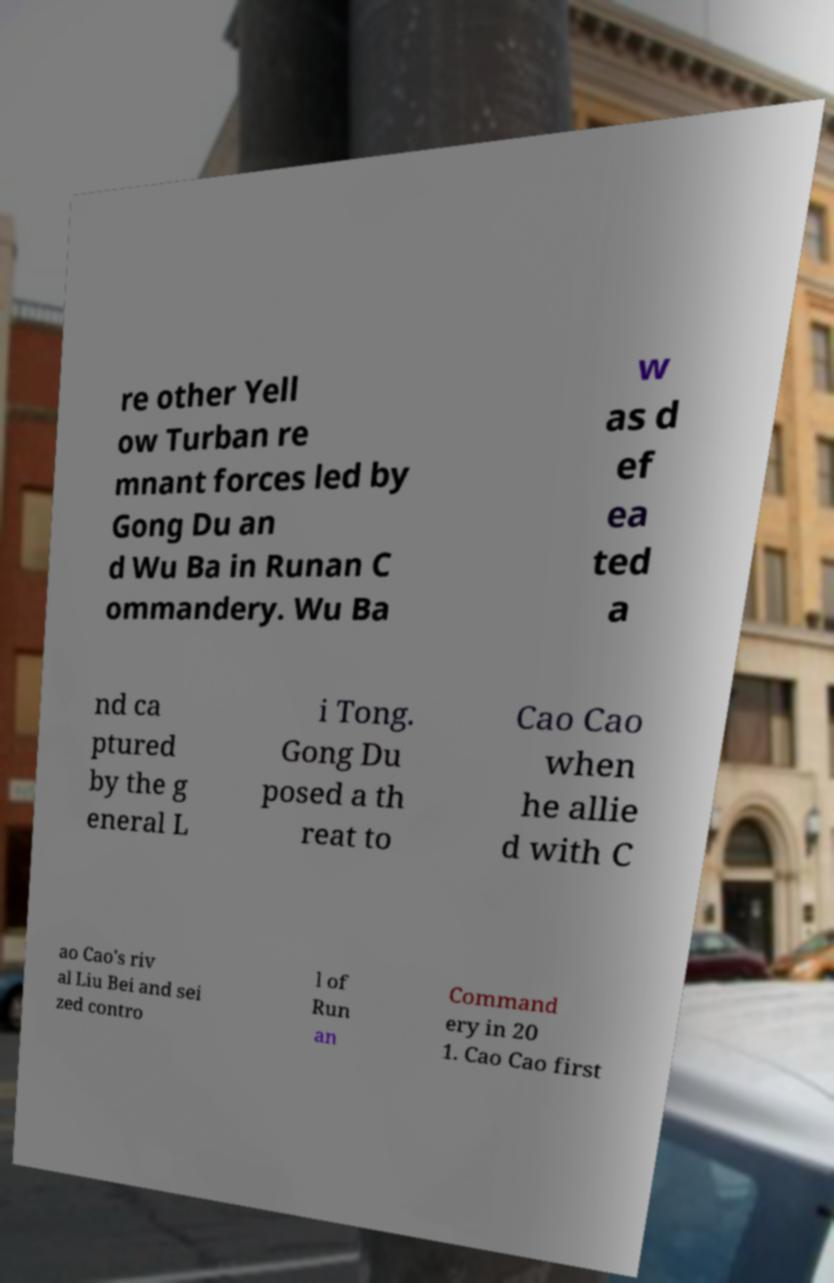Could you assist in decoding the text presented in this image and type it out clearly? re other Yell ow Turban re mnant forces led by Gong Du an d Wu Ba in Runan C ommandery. Wu Ba w as d ef ea ted a nd ca ptured by the g eneral L i Tong. Gong Du posed a th reat to Cao Cao when he allie d with C ao Cao's riv al Liu Bei and sei zed contro l of Run an Command ery in 20 1. Cao Cao first 